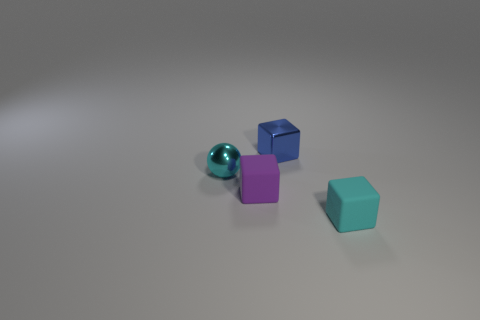Add 1 purple rubber objects. How many objects exist? 5 Subtract all balls. How many objects are left? 3 Subtract 0 green cubes. How many objects are left? 4 Subtract all large cyan metal cylinders. Subtract all tiny metal balls. How many objects are left? 3 Add 4 tiny cyan blocks. How many tiny cyan blocks are left? 5 Add 3 tiny cyan metal objects. How many tiny cyan metal objects exist? 4 